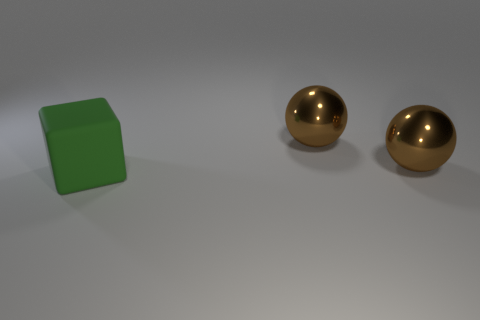Add 1 big blue matte cylinders. How many objects exist? 4 Subtract all balls. How many objects are left? 1 Subtract all green matte cubes. Subtract all large blocks. How many objects are left? 1 Add 2 shiny objects. How many shiny objects are left? 4 Add 2 big yellow matte cylinders. How many big yellow matte cylinders exist? 2 Subtract 0 purple cylinders. How many objects are left? 3 